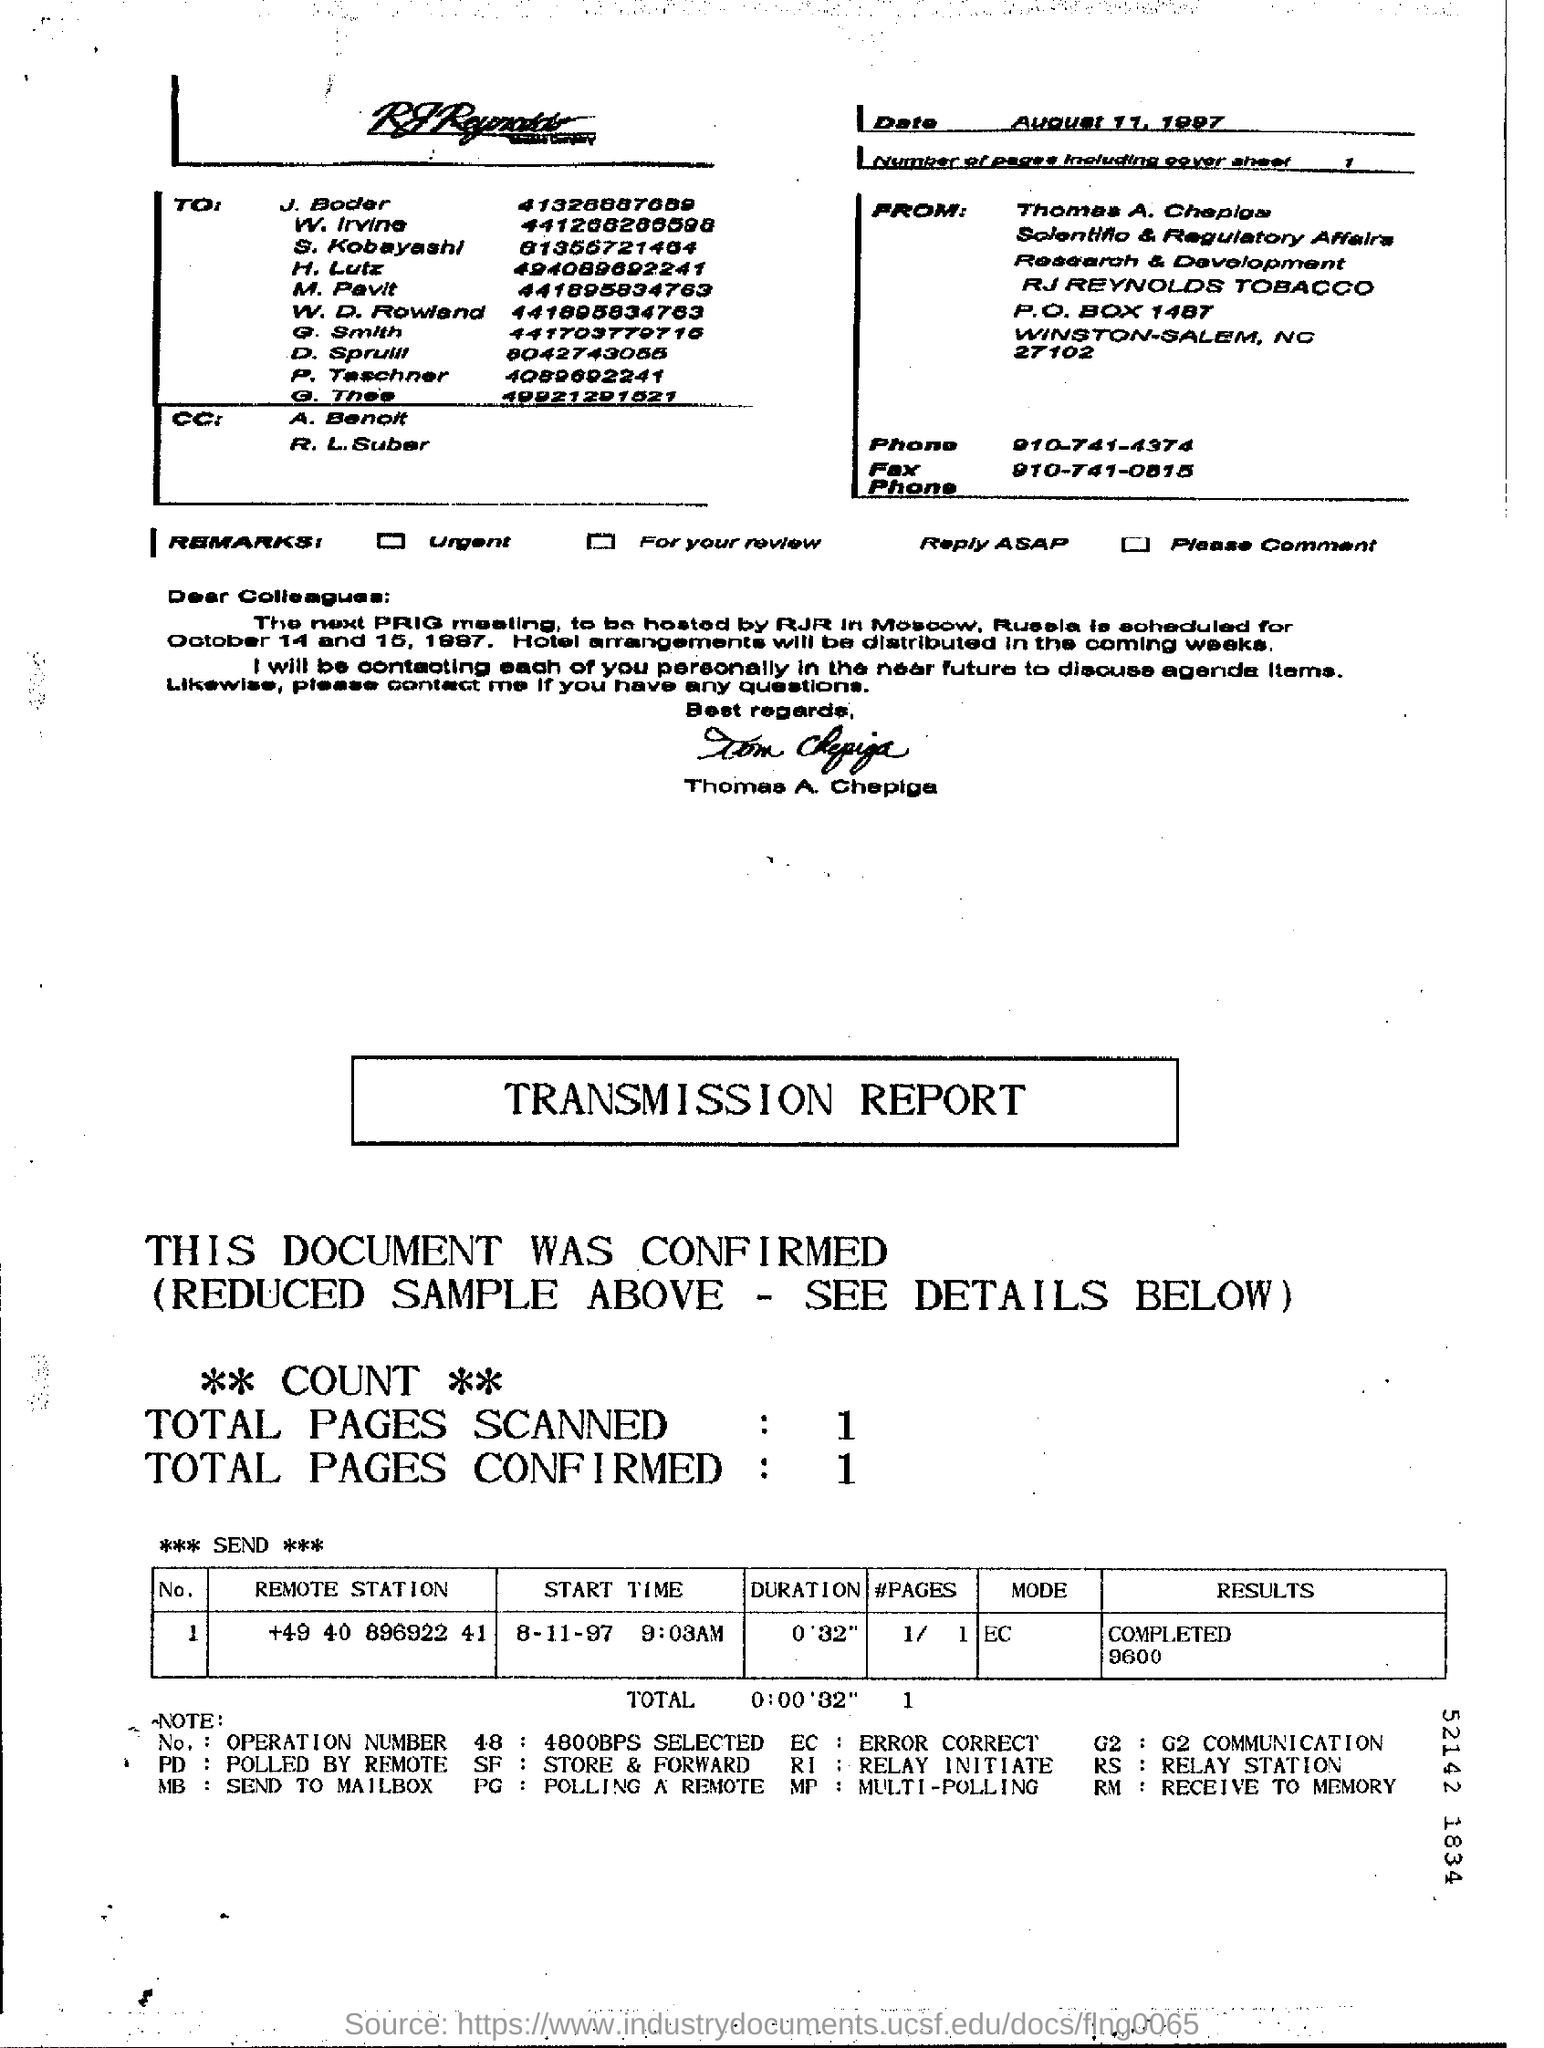Outline some significant characteristics in this image. There are 1 page, including the cover sheet, in the fax. The sender of the FAX is Tom Chepiga. The date mentioned in the fax sheet is August 11, 1997. The mode of the transmission report is EC. The phone number of Thomas A. Chepiga is 910-741-4374. 